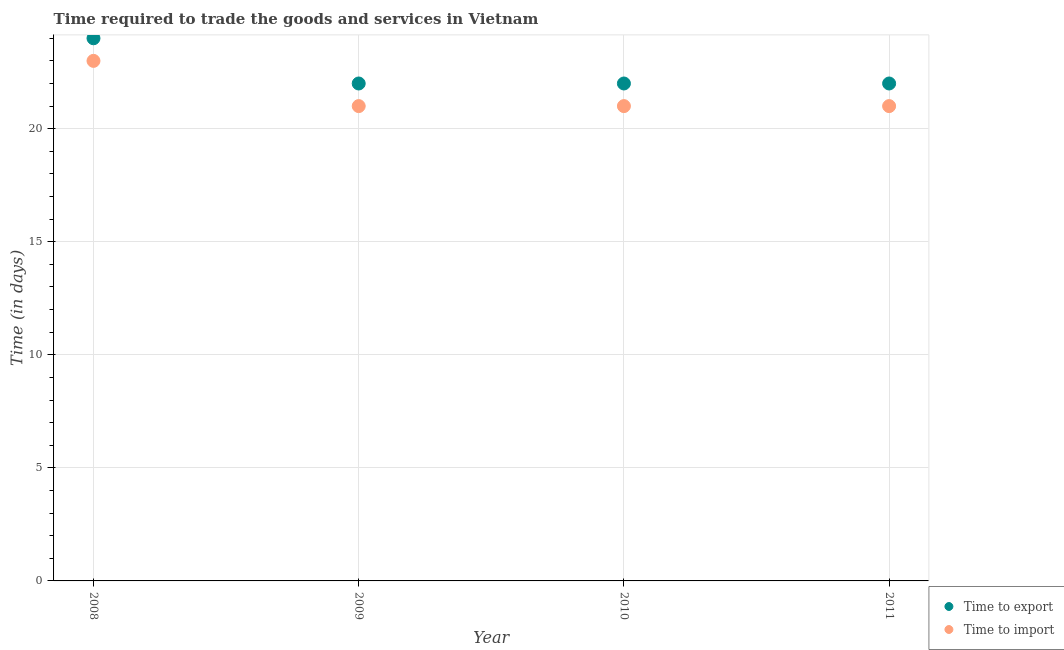How many different coloured dotlines are there?
Provide a succinct answer. 2. What is the time to import in 2011?
Your answer should be very brief. 21. Across all years, what is the maximum time to import?
Your answer should be very brief. 23. Across all years, what is the minimum time to export?
Offer a very short reply. 22. In which year was the time to import maximum?
Give a very brief answer. 2008. In which year was the time to export minimum?
Your response must be concise. 2009. What is the total time to import in the graph?
Give a very brief answer. 86. What is the difference between the time to export in 2008 and that in 2009?
Your answer should be compact. 2. What is the difference between the time to import in 2008 and the time to export in 2009?
Give a very brief answer. 1. What is the average time to import per year?
Your answer should be very brief. 21.5. In the year 2011, what is the difference between the time to import and time to export?
Provide a succinct answer. -1. In how many years, is the time to import greater than 10 days?
Provide a succinct answer. 4. What is the ratio of the time to import in 2008 to that in 2011?
Your response must be concise. 1.1. Is the time to import in 2010 less than that in 2011?
Provide a succinct answer. No. Is the difference between the time to export in 2008 and 2011 greater than the difference between the time to import in 2008 and 2011?
Ensure brevity in your answer.  No. What is the difference between the highest and the second highest time to import?
Offer a very short reply. 2. What is the difference between the highest and the lowest time to import?
Your answer should be compact. 2. In how many years, is the time to import greater than the average time to import taken over all years?
Your answer should be compact. 1. Is the sum of the time to import in 2009 and 2010 greater than the maximum time to export across all years?
Provide a short and direct response. Yes. Is the time to import strictly less than the time to export over the years?
Keep it short and to the point. Yes. How many dotlines are there?
Your answer should be very brief. 2. What is the difference between two consecutive major ticks on the Y-axis?
Provide a succinct answer. 5. Does the graph contain any zero values?
Make the answer very short. No. Does the graph contain grids?
Provide a succinct answer. Yes. Where does the legend appear in the graph?
Your answer should be compact. Bottom right. How many legend labels are there?
Provide a short and direct response. 2. What is the title of the graph?
Ensure brevity in your answer.  Time required to trade the goods and services in Vietnam. Does "Merchandise imports" appear as one of the legend labels in the graph?
Offer a terse response. No. What is the label or title of the X-axis?
Provide a short and direct response. Year. What is the label or title of the Y-axis?
Provide a short and direct response. Time (in days). What is the Time (in days) in Time to import in 2008?
Offer a terse response. 23. What is the Time (in days) of Time to export in 2010?
Make the answer very short. 22. What is the Time (in days) of Time to import in 2010?
Your response must be concise. 21. What is the Time (in days) of Time to export in 2011?
Make the answer very short. 22. Across all years, what is the maximum Time (in days) of Time to import?
Your answer should be compact. 23. Across all years, what is the minimum Time (in days) of Time to export?
Keep it short and to the point. 22. Across all years, what is the minimum Time (in days) in Time to import?
Offer a terse response. 21. What is the difference between the Time (in days) of Time to import in 2008 and that in 2009?
Give a very brief answer. 2. What is the difference between the Time (in days) of Time to export in 2008 and that in 2010?
Offer a very short reply. 2. What is the difference between the Time (in days) of Time to import in 2008 and that in 2010?
Give a very brief answer. 2. What is the difference between the Time (in days) of Time to import in 2008 and that in 2011?
Your answer should be very brief. 2. What is the difference between the Time (in days) in Time to export in 2009 and that in 2010?
Offer a terse response. 0. What is the difference between the Time (in days) in Time to import in 2009 and that in 2010?
Make the answer very short. 0. What is the difference between the Time (in days) in Time to export in 2009 and that in 2011?
Offer a terse response. 0. What is the difference between the Time (in days) in Time to import in 2009 and that in 2011?
Your response must be concise. 0. What is the difference between the Time (in days) in Time to export in 2010 and that in 2011?
Provide a succinct answer. 0. What is the difference between the Time (in days) of Time to export in 2008 and the Time (in days) of Time to import in 2011?
Give a very brief answer. 3. What is the difference between the Time (in days) of Time to export in 2009 and the Time (in days) of Time to import in 2010?
Offer a terse response. 1. What is the difference between the Time (in days) in Time to export in 2010 and the Time (in days) in Time to import in 2011?
Keep it short and to the point. 1. What is the average Time (in days) in Time to import per year?
Offer a very short reply. 21.5. In the year 2009, what is the difference between the Time (in days) in Time to export and Time (in days) in Time to import?
Give a very brief answer. 1. What is the ratio of the Time (in days) in Time to export in 2008 to that in 2009?
Keep it short and to the point. 1.09. What is the ratio of the Time (in days) in Time to import in 2008 to that in 2009?
Give a very brief answer. 1.1. What is the ratio of the Time (in days) of Time to export in 2008 to that in 2010?
Provide a short and direct response. 1.09. What is the ratio of the Time (in days) of Time to import in 2008 to that in 2010?
Your response must be concise. 1.1. What is the ratio of the Time (in days) in Time to import in 2008 to that in 2011?
Provide a succinct answer. 1.1. What is the ratio of the Time (in days) of Time to export in 2009 to that in 2010?
Give a very brief answer. 1. What is the ratio of the Time (in days) in Time to import in 2009 to that in 2011?
Your response must be concise. 1. What is the ratio of the Time (in days) of Time to export in 2010 to that in 2011?
Your answer should be very brief. 1. What is the ratio of the Time (in days) in Time to import in 2010 to that in 2011?
Offer a very short reply. 1. What is the difference between the highest and the second highest Time (in days) of Time to export?
Offer a terse response. 2. What is the difference between the highest and the second highest Time (in days) of Time to import?
Your answer should be compact. 2. 